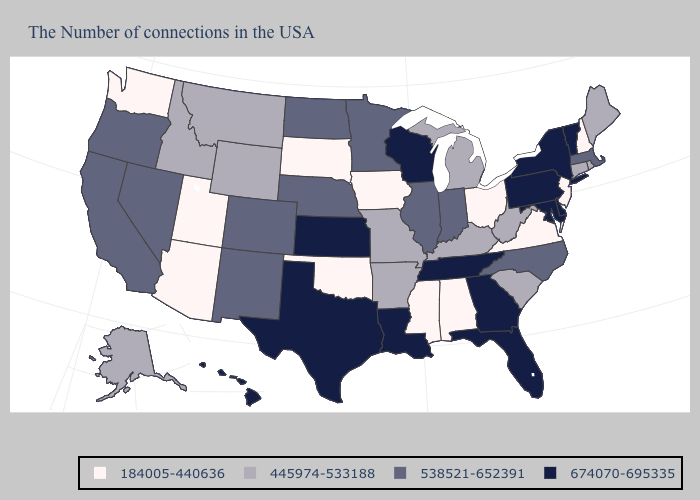Does North Carolina have the lowest value in the USA?
Write a very short answer. No. Among the states that border South Carolina , which have the lowest value?
Concise answer only. North Carolina. Name the states that have a value in the range 445974-533188?
Be succinct. Maine, Rhode Island, Connecticut, South Carolina, West Virginia, Michigan, Kentucky, Missouri, Arkansas, Wyoming, Montana, Idaho, Alaska. What is the highest value in states that border Idaho?
Be succinct. 538521-652391. Which states have the lowest value in the USA?
Keep it brief. New Hampshire, New Jersey, Virginia, Ohio, Alabama, Mississippi, Iowa, Oklahoma, South Dakota, Utah, Arizona, Washington. Name the states that have a value in the range 674070-695335?
Short answer required. Vermont, New York, Delaware, Maryland, Pennsylvania, Florida, Georgia, Tennessee, Wisconsin, Louisiana, Kansas, Texas, Hawaii. What is the value of South Carolina?
Be succinct. 445974-533188. Name the states that have a value in the range 674070-695335?
Answer briefly. Vermont, New York, Delaware, Maryland, Pennsylvania, Florida, Georgia, Tennessee, Wisconsin, Louisiana, Kansas, Texas, Hawaii. Does the first symbol in the legend represent the smallest category?
Concise answer only. Yes. Does Arizona have the lowest value in the USA?
Be succinct. Yes. What is the value of Vermont?
Answer briefly. 674070-695335. Name the states that have a value in the range 538521-652391?
Be succinct. Massachusetts, North Carolina, Indiana, Illinois, Minnesota, Nebraska, North Dakota, Colorado, New Mexico, Nevada, California, Oregon. Does Oregon have a higher value than Wyoming?
Give a very brief answer. Yes. Does Michigan have the lowest value in the MidWest?
Give a very brief answer. No. What is the highest value in the USA?
Keep it brief. 674070-695335. 